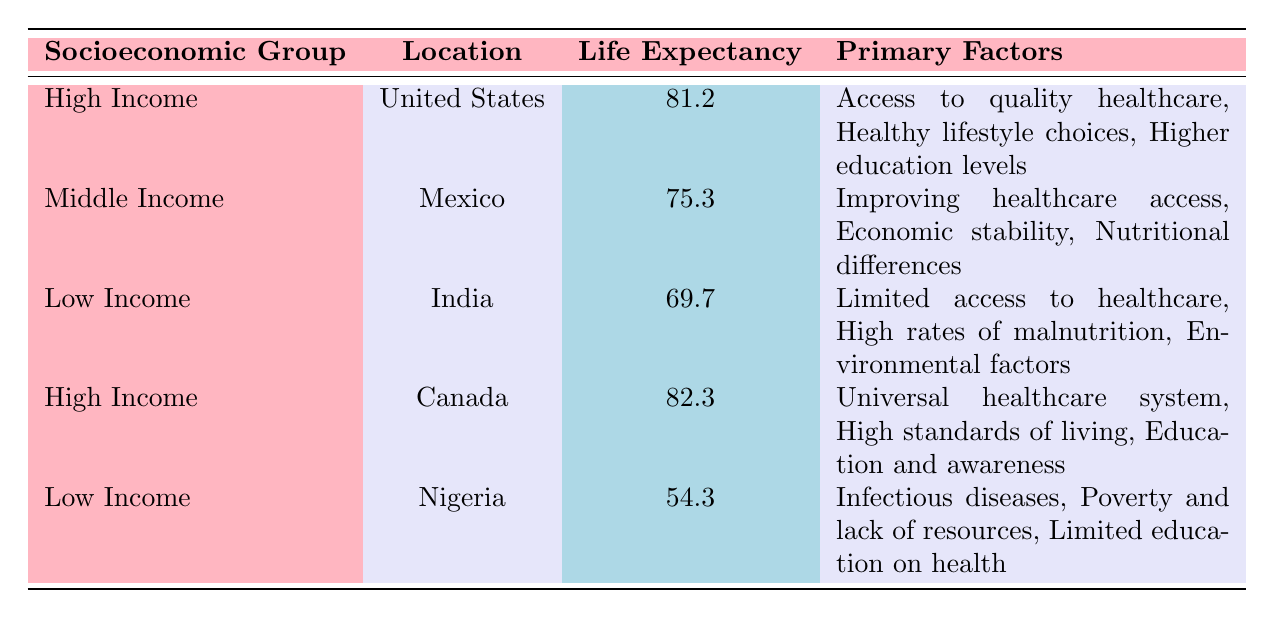What is the average life expectancy for high-income groups in the table? There are two high-income entries, one from the United States (81.2 years) and one from Canada (82.3 years). To calculate the average, we add these together: 81.2 + 82.3 = 163.5, and then divide by 2, which gives us 163.5 / 2 = 81.75 years.
Answer: 81.75 years Which country has the lowest life expectancy? The table shows that Nigeria has the lowest life expectancy at 54.3 years, compared to other countries listed.
Answer: Nigeria True or false: The primary factors for high-income groups include access to quality healthcare. Both high-income entries in the table (United States and Canada) list access to quality healthcare as a primary factor. Thus, the statement is true.
Answer: True What is the difference in average life expectancy between low-income groups in India and Nigeria? The average life expectancy in India is 69.7 years, while in Nigeria it is 54.3 years. To find the difference, subtract the lower value from the higher: 69.7 - 54.3 = 15.4 years.
Answer: 15.4 years Which socioeconomic group has the highest average life expectancy, and what is that number? In the data, the high-income group in Canada has the highest average life expectancy at 82.3 years, which is more than the other groups.
Answer: High Income, 82.3 years True or false: All countries listed in the table have a life expectancy above 70 years. Nigeria has a life expectancy of 54.3 years, which is below 70 years, so the statement is false.
Answer: False Calculate the overall average life expectancy of all the groups combined. The life expectancies are 81.2 (US), 75.3 (Mexico), 69.7 (India), 82.3 (Canada), and 54.3 (Nigeria). The sum of these values is 81.2 + 75.3 + 69.7 + 82.3 + 54.3 = 362.8 years. There are 5 groups, so we divide by 5: 362.8 / 5 = 72.56 years.
Answer: 72.56 years What common primary factor is listed for both high-income countries in the table? Both the United States and Canada mention access to quality healthcare as a common primary factor influencing their higher life expectancy.
Answer: Access to quality healthcare What factors contribute to the lower life expectancy in Nigeria compared to India? Nigeria's primary factors include infectious diseases, poverty, and limited health education, while India's primary factors focus on limited access to healthcare and malnutrition. This suggests Nigeria faces more severe health challenges, leading to even lower life expectancy.
Answer: Infectious diseases, poverty, limited education on health 